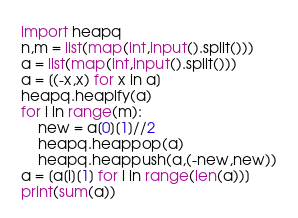Convert code to text. <code><loc_0><loc_0><loc_500><loc_500><_Python_>import heapq
n,m = list(map(int,input().split()))
a = list(map(int,input().split()))
a = [(-x,x) for x in a]
heapq.heapify(a)
for i in range(m):
    new = a[0][1]//2
    heapq.heappop(a)
    heapq.heappush(a,(-new,new))
a = [a[i][1] for i in range(len(a))]
print(sum(a))</code> 